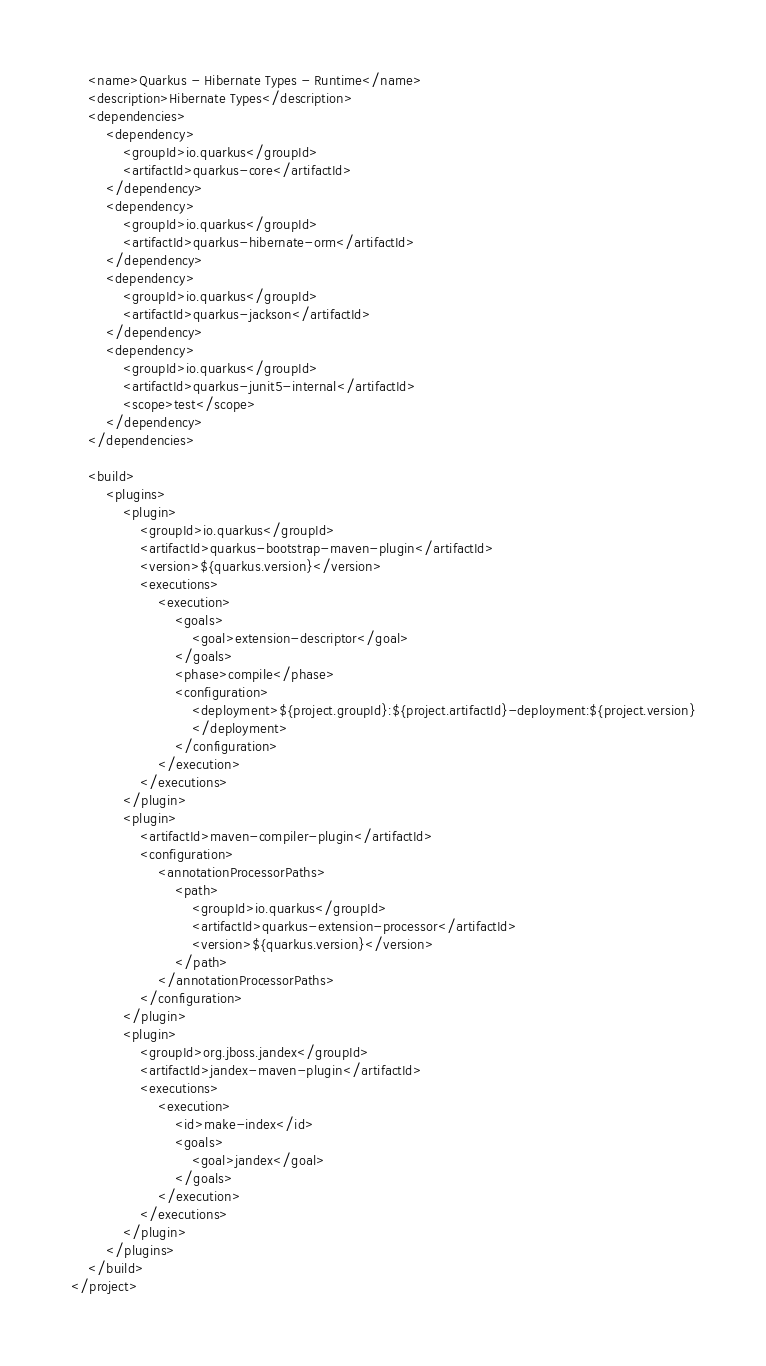<code> <loc_0><loc_0><loc_500><loc_500><_XML_>    <name>Quarkus - Hibernate Types - Runtime</name>
    <description>Hibernate Types</description>
    <dependencies>
        <dependency>
            <groupId>io.quarkus</groupId>
            <artifactId>quarkus-core</artifactId>
        </dependency>
        <dependency>
            <groupId>io.quarkus</groupId>
            <artifactId>quarkus-hibernate-orm</artifactId>
        </dependency>
        <dependency>
            <groupId>io.quarkus</groupId>
            <artifactId>quarkus-jackson</artifactId>
        </dependency>
        <dependency>
            <groupId>io.quarkus</groupId>
            <artifactId>quarkus-junit5-internal</artifactId>
            <scope>test</scope>
        </dependency>
    </dependencies>

    <build>
        <plugins>
            <plugin>
                <groupId>io.quarkus</groupId>
                <artifactId>quarkus-bootstrap-maven-plugin</artifactId>
                <version>${quarkus.version}</version>
                <executions>
                    <execution>
                        <goals>
                            <goal>extension-descriptor</goal>
                        </goals>
                        <phase>compile</phase>
                        <configuration>
                            <deployment>${project.groupId}:${project.artifactId}-deployment:${project.version}
                            </deployment>
                        </configuration>
                    </execution>
                </executions>
            </plugin>
            <plugin>
                <artifactId>maven-compiler-plugin</artifactId>
                <configuration>
                    <annotationProcessorPaths>
                        <path>
                            <groupId>io.quarkus</groupId>
                            <artifactId>quarkus-extension-processor</artifactId>
                            <version>${quarkus.version}</version>
                        </path>
                    </annotationProcessorPaths>
                </configuration>
            </plugin>
            <plugin>
                <groupId>org.jboss.jandex</groupId>
                <artifactId>jandex-maven-plugin</artifactId>
                <executions>
                    <execution>
                        <id>make-index</id>
                        <goals>
                            <goal>jandex</goal>
                        </goals>
                    </execution>
                </executions>
            </plugin>
        </plugins>
    </build>
</project>
</code> 